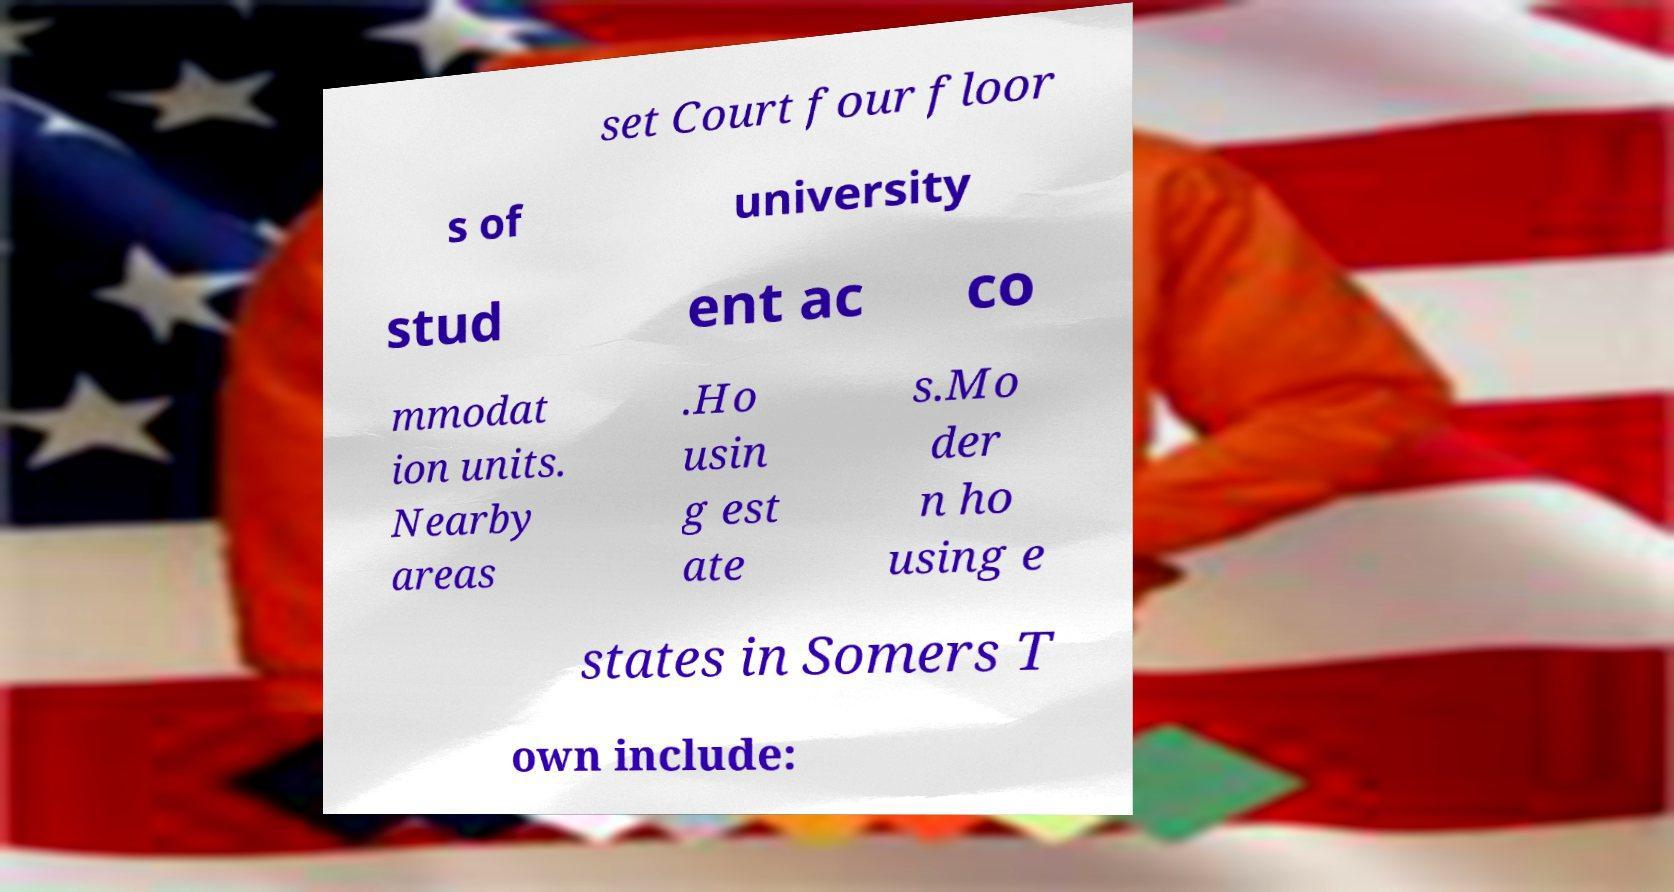What messages or text are displayed in this image? I need them in a readable, typed format. set Court four floor s of university stud ent ac co mmodat ion units. Nearby areas .Ho usin g est ate s.Mo der n ho using e states in Somers T own include: 